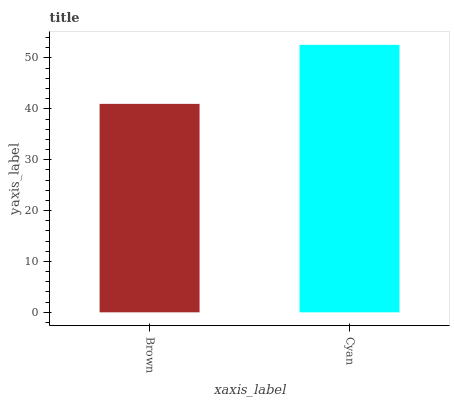Is Brown the minimum?
Answer yes or no. Yes. Is Cyan the maximum?
Answer yes or no. Yes. Is Cyan the minimum?
Answer yes or no. No. Is Cyan greater than Brown?
Answer yes or no. Yes. Is Brown less than Cyan?
Answer yes or no. Yes. Is Brown greater than Cyan?
Answer yes or no. No. Is Cyan less than Brown?
Answer yes or no. No. Is Cyan the high median?
Answer yes or no. Yes. Is Brown the low median?
Answer yes or no. Yes. Is Brown the high median?
Answer yes or no. No. Is Cyan the low median?
Answer yes or no. No. 